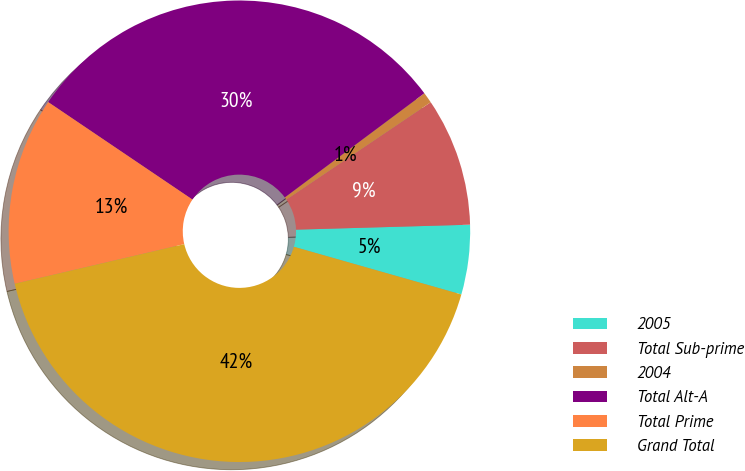Convert chart. <chart><loc_0><loc_0><loc_500><loc_500><pie_chart><fcel>2005<fcel>Total Sub-prime<fcel>2004<fcel>Total Alt-A<fcel>Total Prime<fcel>Grand Total<nl><fcel>4.87%<fcel>8.99%<fcel>0.76%<fcel>30.34%<fcel>13.11%<fcel>41.93%<nl></chart> 